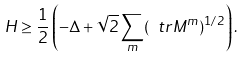<formula> <loc_0><loc_0><loc_500><loc_500>H \geq \frac { 1 } { 2 } \left ( - \Delta + \sqrt { 2 } \sum _ { m } ( \ t r M ^ { m } ) ^ { 1 / 2 } \right ) .</formula> 